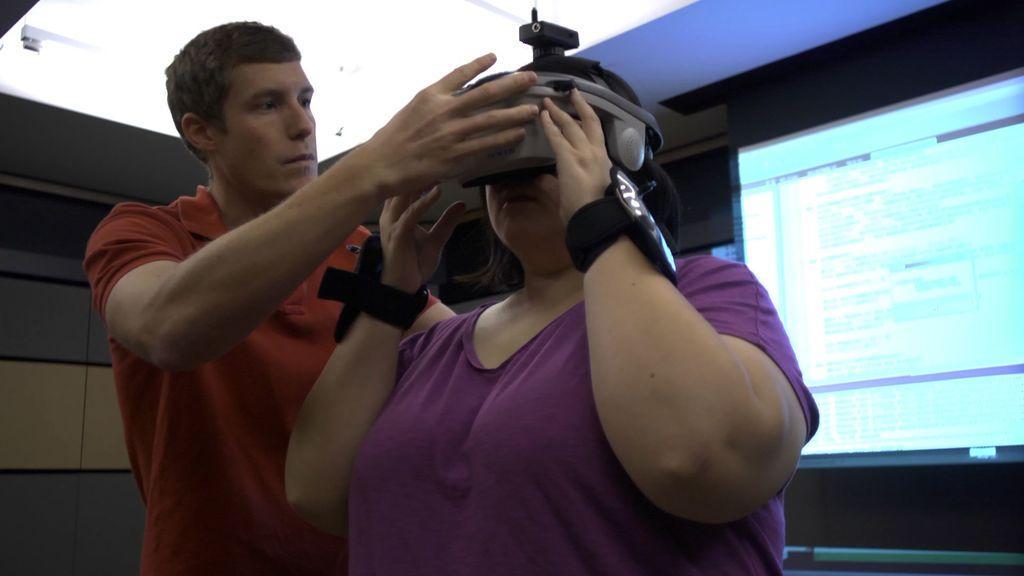Can you describe this image briefly? This is a zoomed in picture seems to be clicked inside. On the right there is a woman wearing t-shirt and a device and standing on the ground. On the left there is a person wearing a t-shirt and standing on the ground. In the background we can see the digital screen, wall and the roof and we can see the text on the screen. 